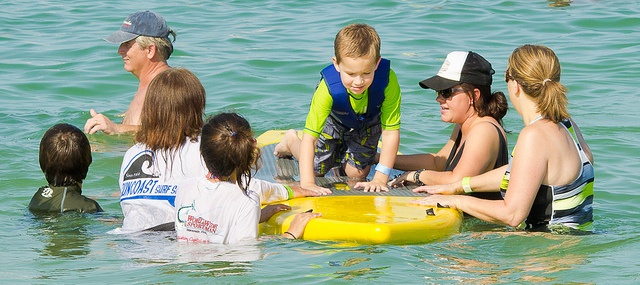Describe the objects in this image and their specific colors. I can see people in lightblue, tan, black, and ivory tones, people in lightblue, black, tan, and olive tones, people in lightblue, lightgray, maroon, and gray tones, surfboard in lightblue, gold, khaki, darkgray, and olive tones, and people in lightblue, black, and tan tones in this image. 